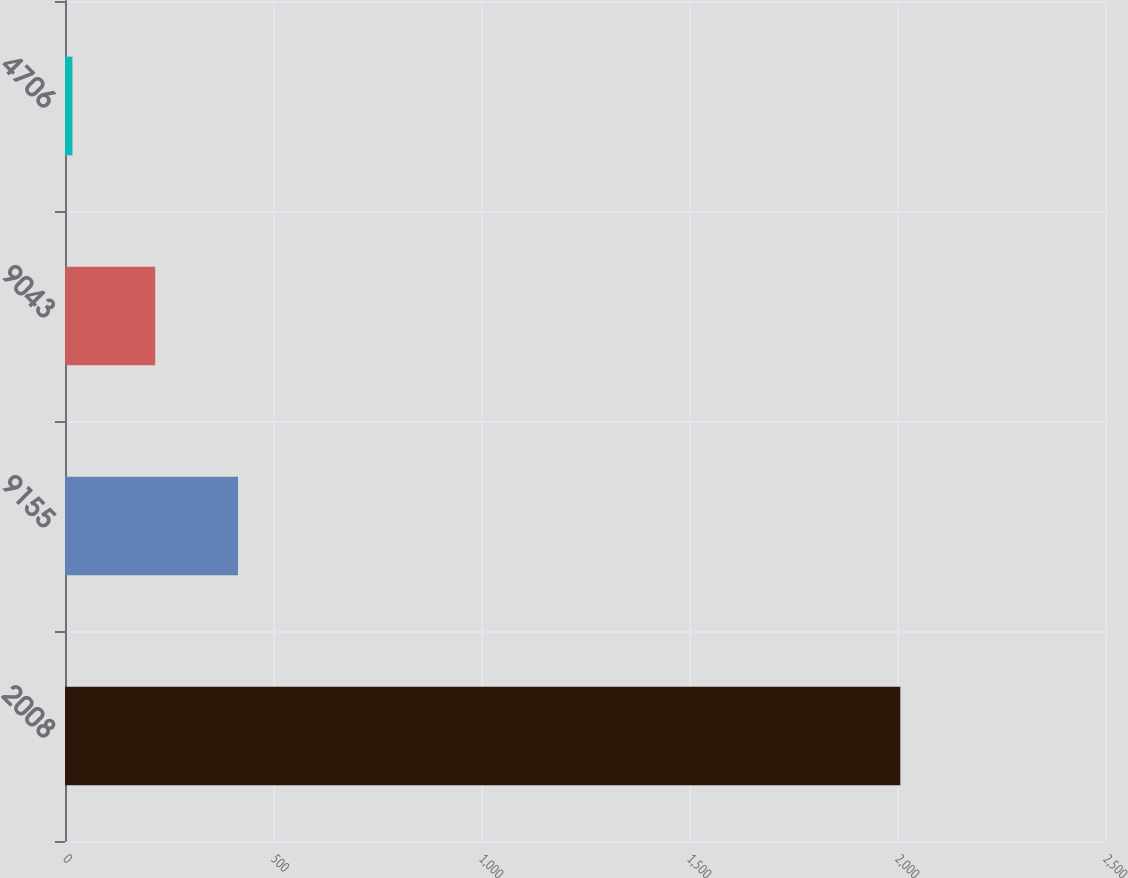<chart> <loc_0><loc_0><loc_500><loc_500><bar_chart><fcel>2008<fcel>9155<fcel>9043<fcel>4706<nl><fcel>2008<fcel>415.88<fcel>216.87<fcel>17.86<nl></chart> 